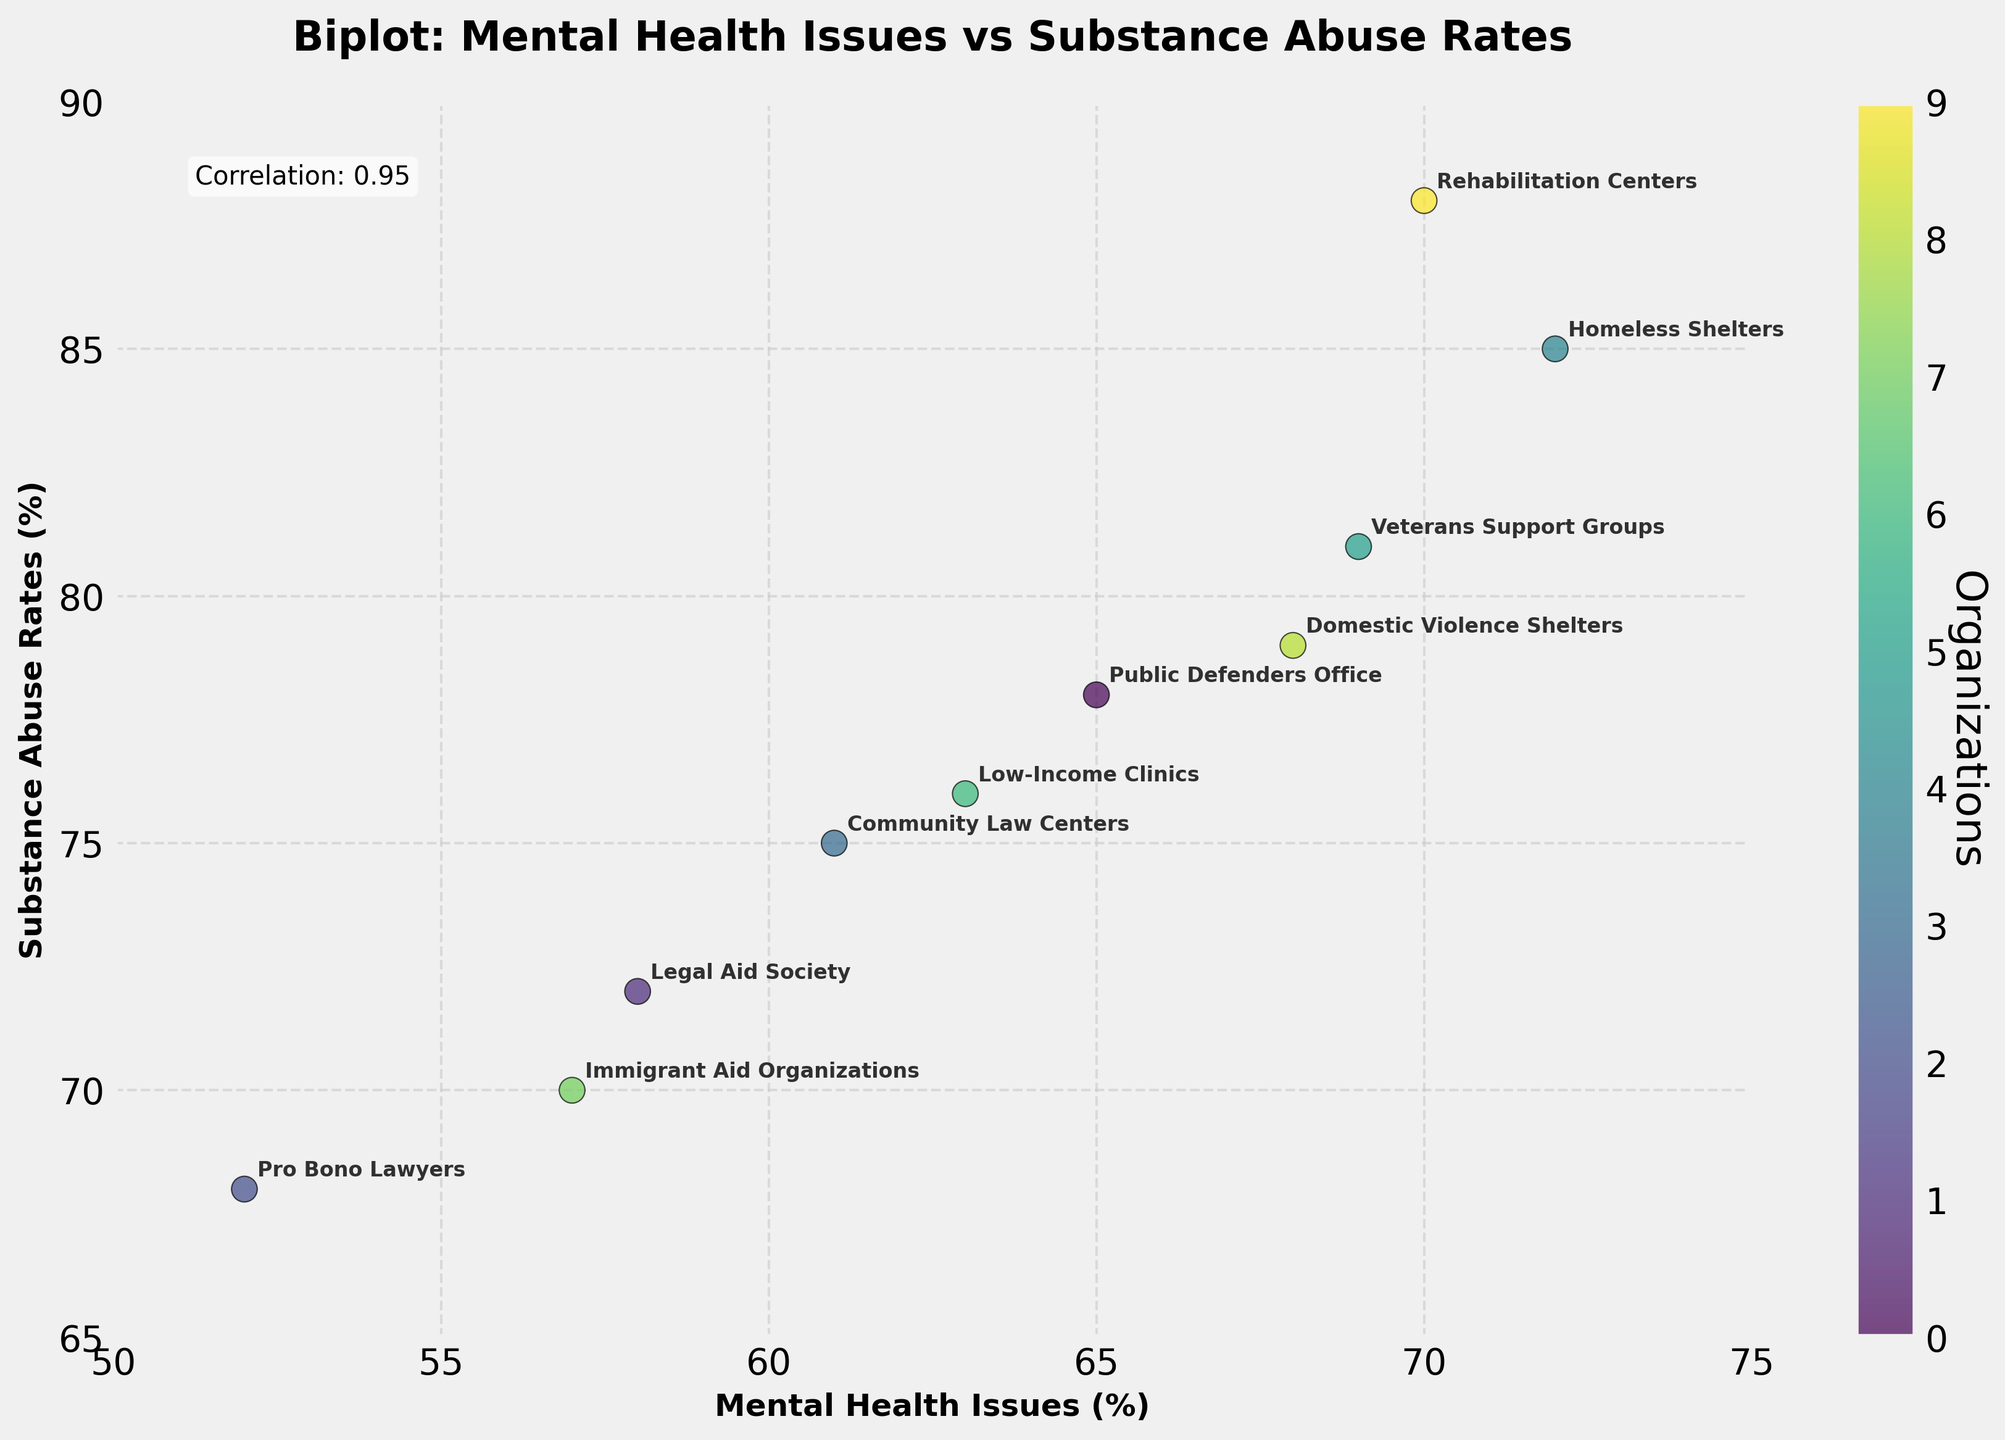what is the title of the figure? The title is displayed prominently at the top of the figure. It describes what the plot is about.
Answer: Biplot: Mental Health Issues vs Substance Abuse Rates How many organizations are included in the plot? By counting the different labels annotated on the scatter plot, we can determine the number of organizations represented.
Answer: 10 Which organization has the highest rate of substance abuse? By referring to the y-axis values and identifying the point with the highest value, we see it is annotated.
Answer: Rehabilitation Centers What is the correlation coefficient between mental health issues and substance abuse rates? The correlation coefficient is provided in the plot, typically displayed as text on the figure.
Answer: 0.82 Which two organizations have the closest mental health issue rates? Checking the mental health rates on the x-axis and comparing how close the points are visually, we can determine the proximity.
Answer: Public Defenders Office and Rehabilitation Centers (65 and 70) Compare Substance Abuse Rates of Community Law Centers and Low-Income Clinics By referring to the y-axis values for each organization, you can compare their levels.
Answer: Community Law Centers: 75, Low-Income Clinics: 76 Which organization has the lowest mental health issues rate, and what is the corresponding substance abuse rate for that organization? Checking the figures on the x-axis and identifying the lowest value, then finding the related substance abuse rate on the y-axis.
Answer: Pro Bono Lawyers: 52, Substance Abuse Rate: 68 What is the approximate range of mental health issues in the organizations represented on this plot? By looking at the smallest and largest x-values on the plot, these represent the minimum and maximum percentages of mental health issues.
Answer: 52 to 72 Calculate the difference in substance abuse rates between Homeless Shelters and Immigrant Aid Organizations. Subtract the substance abuse rate for Immigrant Aid Organizations from that of Homeless Shelters by comparing their y-axis values.
Answer: 15 (85 - 70) What insight can you derive from the colorbar included in the plot along with the data points? A colorbar provides additional context or categorization for the data points, often used to show the scale or distribution of a secondary variable. Here, it represents different organizations.
Answer: It helps to differentiate organizations 